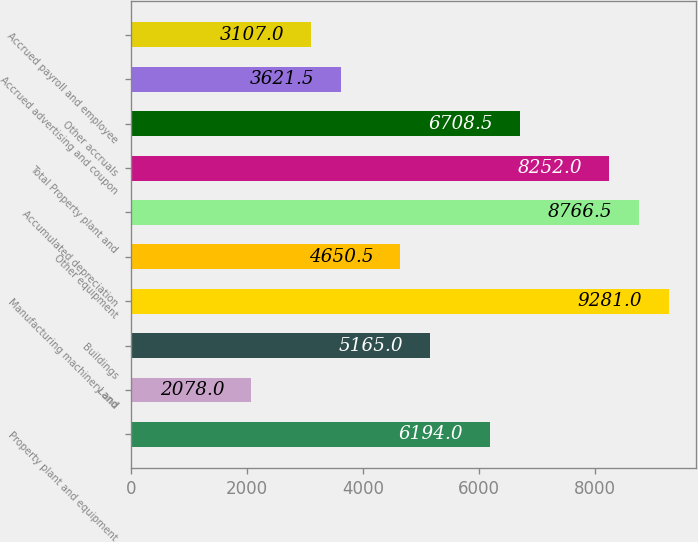Convert chart to OTSL. <chart><loc_0><loc_0><loc_500><loc_500><bar_chart><fcel>Property plant and equipment<fcel>Land<fcel>Buildings<fcel>Manufacturing machinery and<fcel>Other equipment<fcel>Accumulated depreciation<fcel>Total Property plant and<fcel>Other accruals<fcel>Accrued advertising and coupon<fcel>Accrued payroll and employee<nl><fcel>6194<fcel>2078<fcel>5165<fcel>9281<fcel>4650.5<fcel>8766.5<fcel>8252<fcel>6708.5<fcel>3621.5<fcel>3107<nl></chart> 